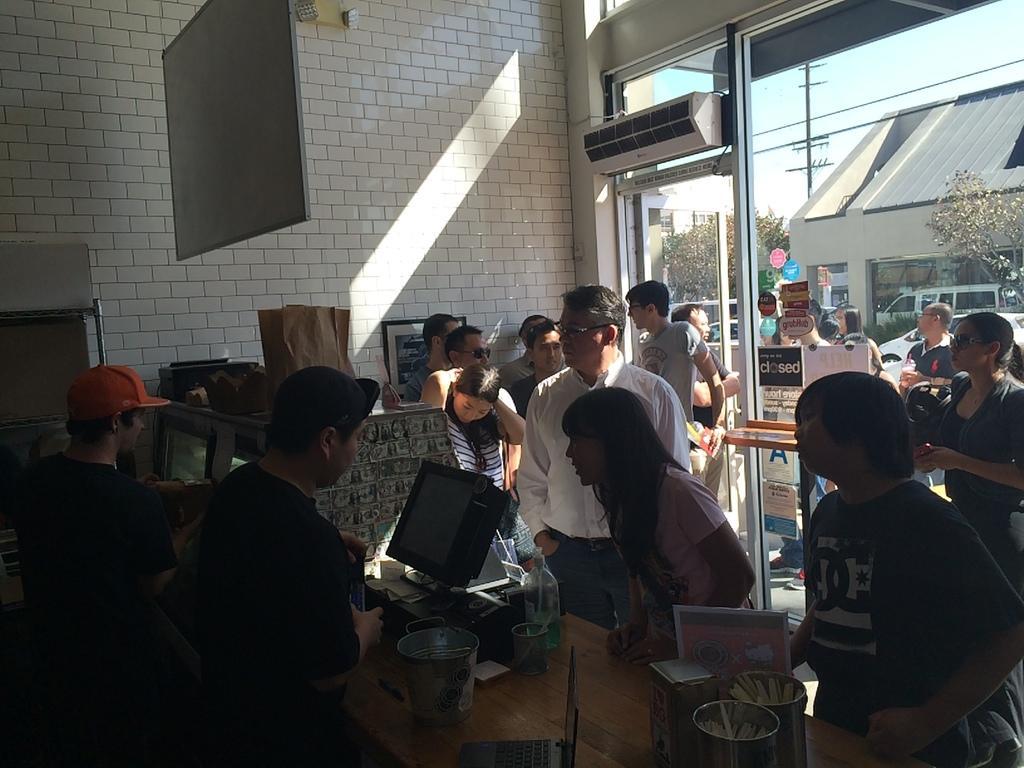How would you summarize this image in a sentence or two? In this image there are people standing and there are two people in front of a monitor. Image also consists of a laptop, bucket, container, name board and also bottle on the counter. In the background we can see a plain wall, frame attached to the wall and also glass door and behind the glass door we can see few people standing. Trees and electrical poles with wires are also visible in this image. 